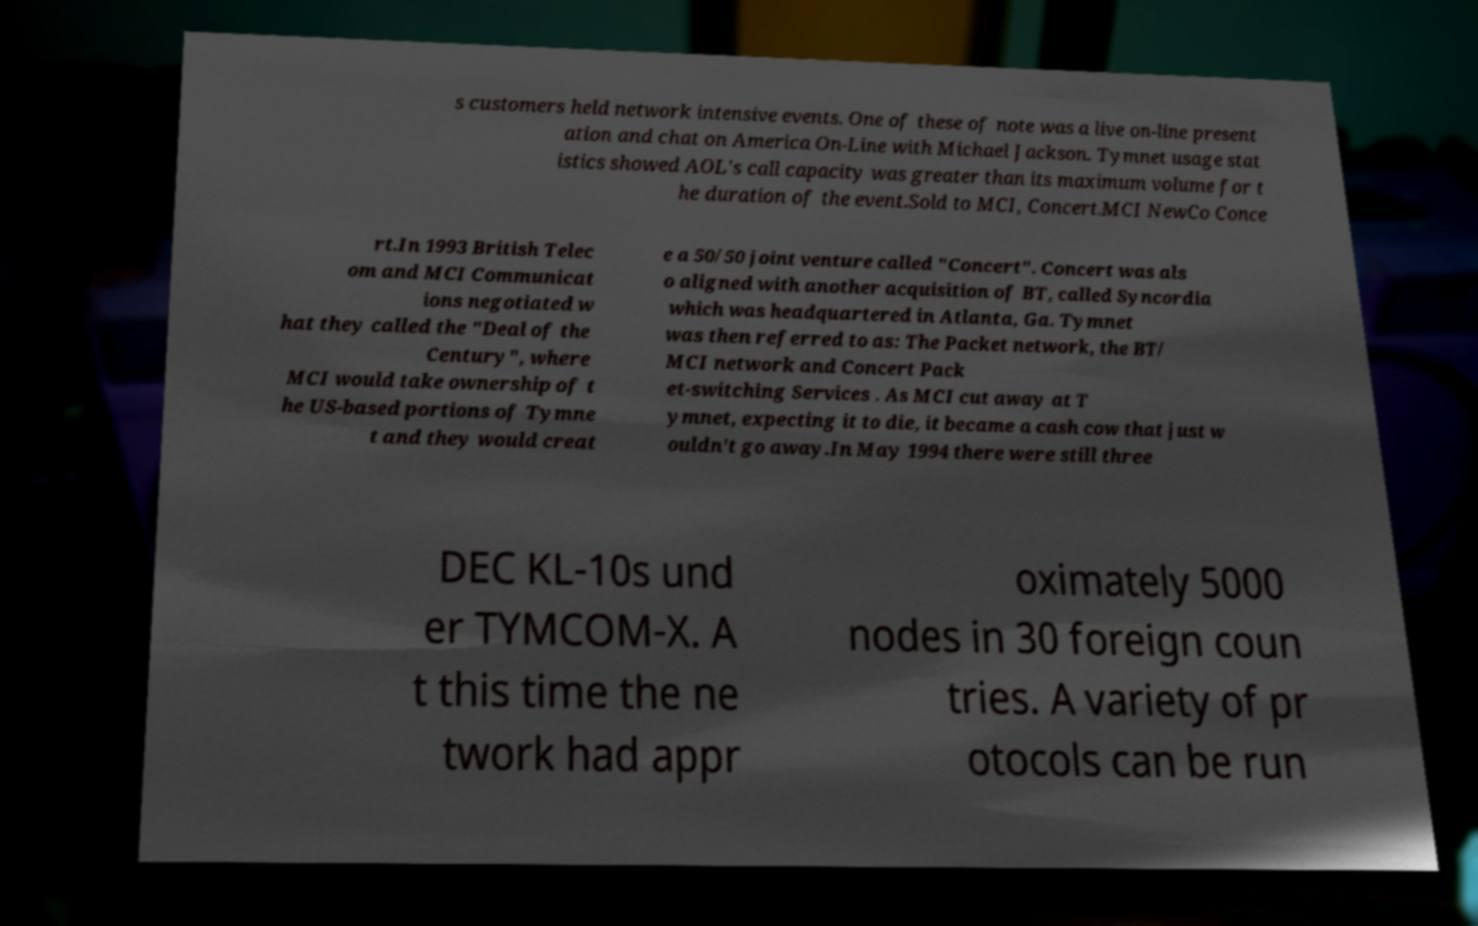Please identify and transcribe the text found in this image. s customers held network intensive events. One of these of note was a live on-line present ation and chat on America On-Line with Michael Jackson. Tymnet usage stat istics showed AOL's call capacity was greater than its maximum volume for t he duration of the event.Sold to MCI, Concert.MCI NewCo Conce rt.In 1993 British Telec om and MCI Communicat ions negotiated w hat they called the "Deal of the Century", where MCI would take ownership of t he US-based portions of Tymne t and they would creat e a 50/50 joint venture called "Concert". Concert was als o aligned with another acquisition of BT, called Syncordia which was headquartered in Atlanta, Ga. Tymnet was then referred to as: The Packet network, the BT/ MCI network and Concert Pack et-switching Services . As MCI cut away at T ymnet, expecting it to die, it became a cash cow that just w ouldn't go away.In May 1994 there were still three DEC KL-10s und er TYMCOM-X. A t this time the ne twork had appr oximately 5000 nodes in 30 foreign coun tries. A variety of pr otocols can be run 